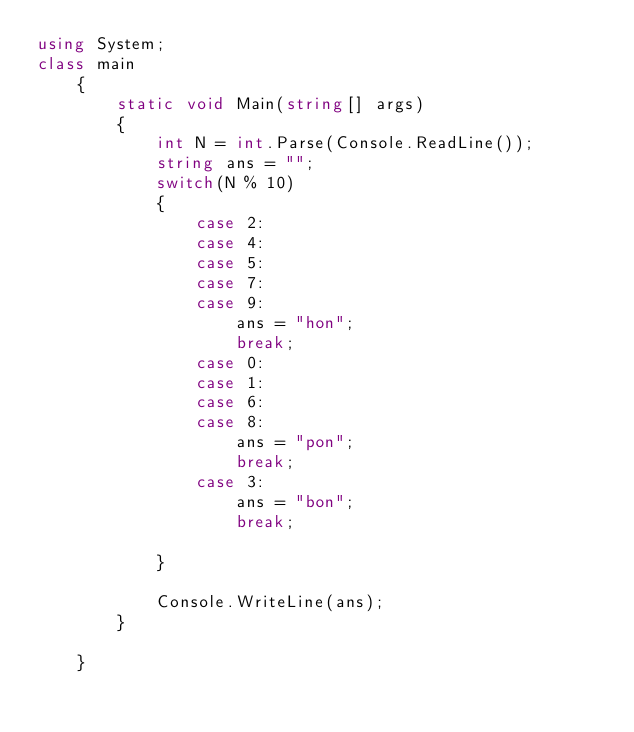Convert code to text. <code><loc_0><loc_0><loc_500><loc_500><_C#_>using System;
class main
    {
        static void Main(string[] args)
        {
            int N = int.Parse(Console.ReadLine());
            string ans = "";
            switch(N % 10)
            {
                case 2:
                case 4:
                case 5:
                case 7:
                case 9:
                    ans = "hon";
                    break;
                case 0:
                case 1:
                case 6:
                case 8:
                    ans = "pon";
                    break;
                case 3:
                    ans = "bon";
                    break;
                    
            }
 
            Console.WriteLine(ans);
        }
        
    }</code> 